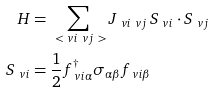<formula> <loc_0><loc_0><loc_500><loc_500>H & = \sum _ { \ < \ v i \ v j \ > } J _ { \ v i \ v j } \, S _ { \ v i } \cdot S _ { \ v j } \\ S _ { \ v i } & = \frac { 1 } { 2 } f _ { \ v i \alpha } ^ { \dag } \sigma _ { \alpha \beta } f _ { \ v i \beta }</formula> 